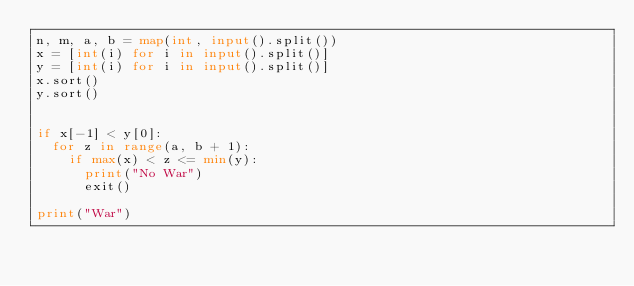<code> <loc_0><loc_0><loc_500><loc_500><_Python_>n, m, a, b = map(int, input().split())
x = [int(i) for i in input().split()]
y = [int(i) for i in input().split()]
x.sort()
y.sort()


if x[-1] < y[0]:
  for z in range(a, b + 1):
    if max(x) < z <= min(y):
      print("No War")
      exit()

print("War")</code> 